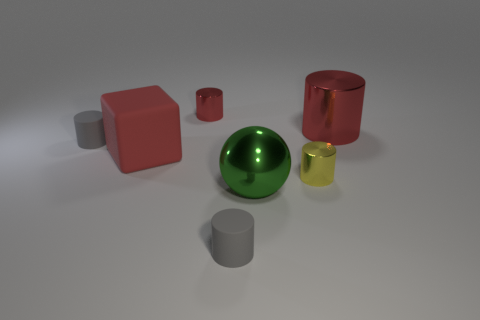There is a big thing that is the same color as the rubber cube; what is it made of?
Make the answer very short. Metal. Is the number of large things to the right of the big red rubber block the same as the number of tiny rubber cylinders?
Your answer should be compact. Yes. What number of green objects are the same material as the small red cylinder?
Your answer should be very brief. 1. Is the number of large green matte blocks less than the number of tiny red things?
Your answer should be very brief. Yes. Is the color of the large object behind the matte cube the same as the cube?
Offer a terse response. Yes. There is a tiny cylinder behind the small gray matte object that is to the left of the red cube; how many red metallic things are on the left side of it?
Offer a very short reply. 0. What number of green objects are behind the block?
Your answer should be very brief. 0. What color is the large object that is the same shape as the tiny red metallic thing?
Offer a terse response. Red. What is the cylinder that is behind the tiny yellow metal object and to the right of the large metallic ball made of?
Your response must be concise. Metal. There is a thing that is in front of the shiny ball; is it the same size as the rubber cube?
Provide a short and direct response. No. 